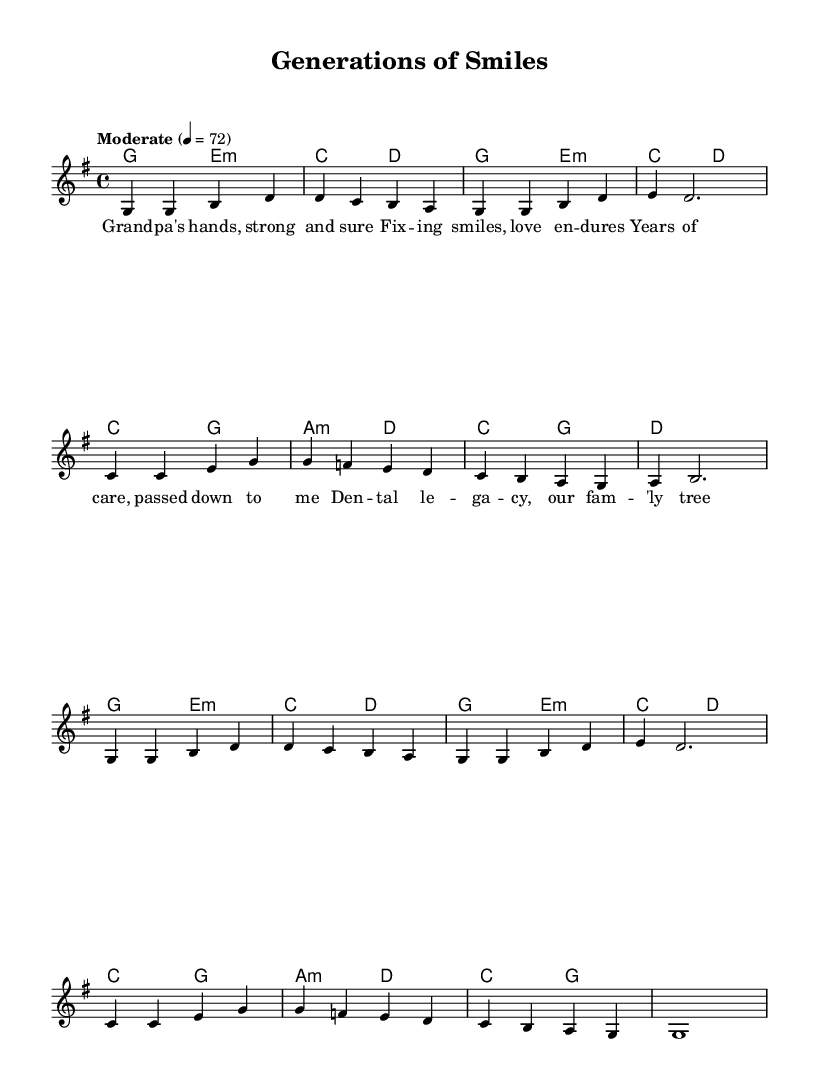What is the key signature of this music? The key signature shown is G major, which contains one sharp (F sharp). This can be determined by looking at the key signature placement at the beginning of the staff.
Answer: G major What is the time signature of this music? The time signature is 4/4, indicated at the beginning of the piece. This means there are four beats per measure, and a quarter note receives one beat.
Answer: 4/4 What is the tempo marking for this piece? The tempo marking is "Moderate" with a metronome marking of 72 beats per minute, indicated at the beginning. This suggests a moderate pace for the performance.
Answer: Moderate How many measures are there in the melody? Counting the vertical lines (bar lines) in the melody part, there are a total of 12 measures. Each measure is separated by these lines.
Answer: 12 What is the theme of the lyrics? The lyrics reflect on family connection through the theme of dental care and legacy, emphasizing the love and care passed down through generations. The lyrics describe the influence of a grandparent within a family context.
Answer: Family legacy What chords are used in the first measure? The first measure features a G major chord in the harmonies part, as indicated by the chord symbol above the measure. This chord is played along with the melody in that measure.
Answer: G major Which note serves as the tonic in this piece? The tonic note is G, as it is the first note of the scale in G major and is emphasized at the start of the melody. This is the central note around which the piece is based.
Answer: G 